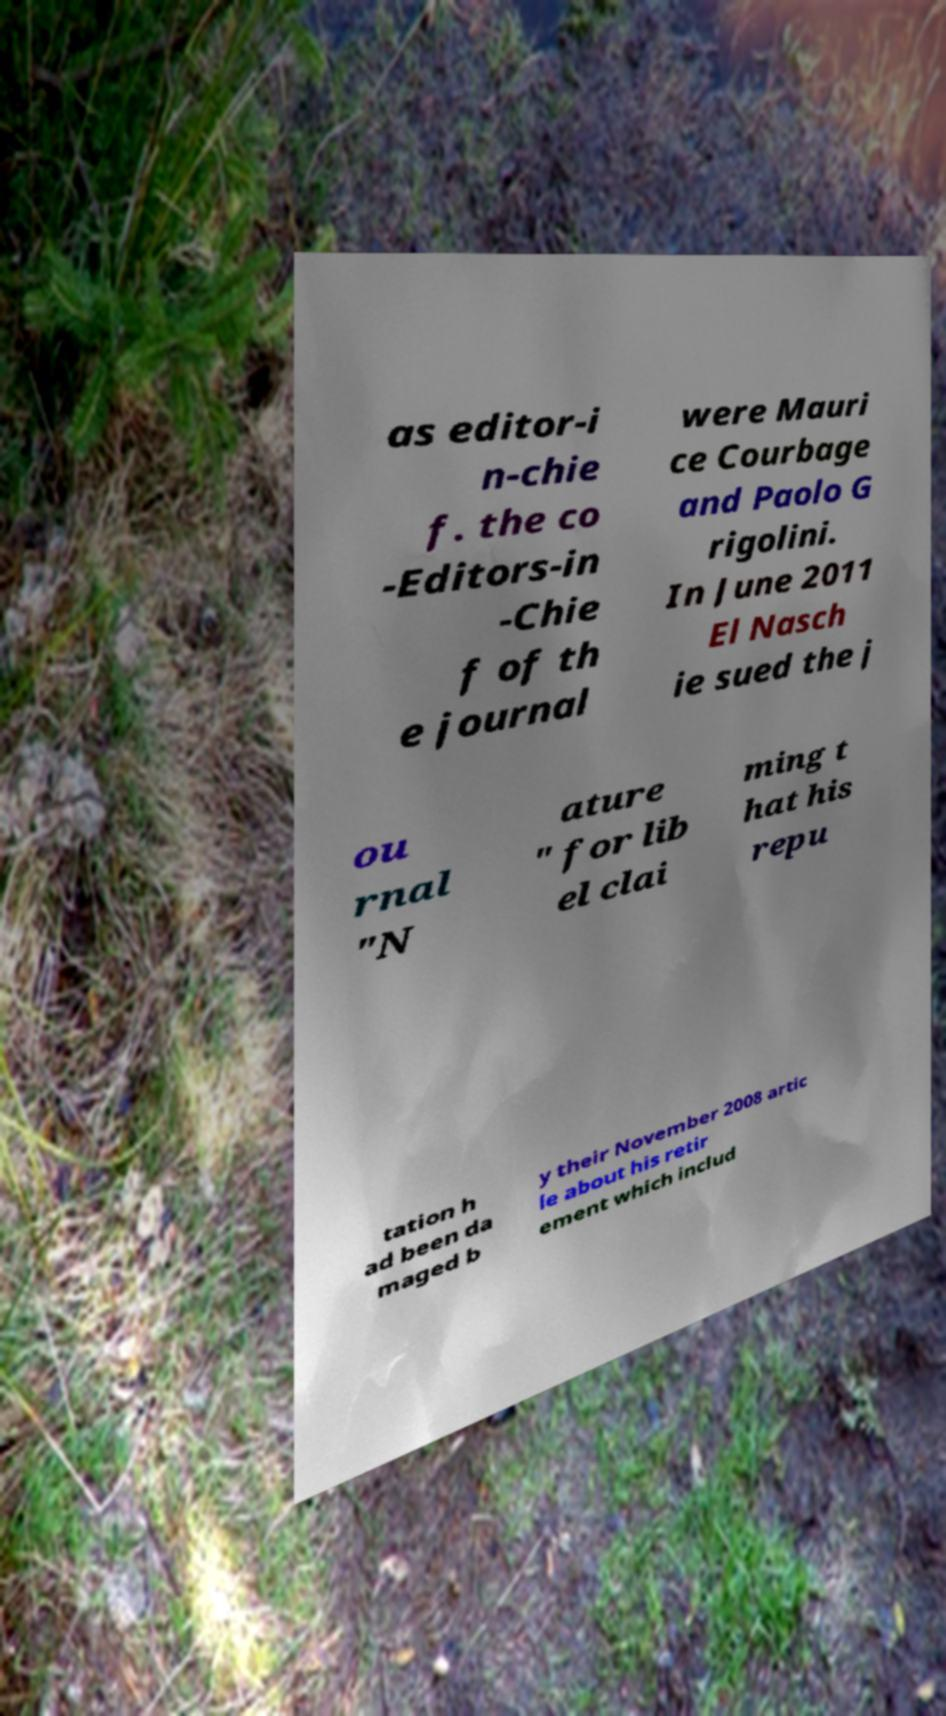Please read and relay the text visible in this image. What does it say? as editor-i n-chie f. the co -Editors-in -Chie f of th e journal were Mauri ce Courbage and Paolo G rigolini. In June 2011 El Nasch ie sued the j ou rnal "N ature " for lib el clai ming t hat his repu tation h ad been da maged b y their November 2008 artic le about his retir ement which includ 